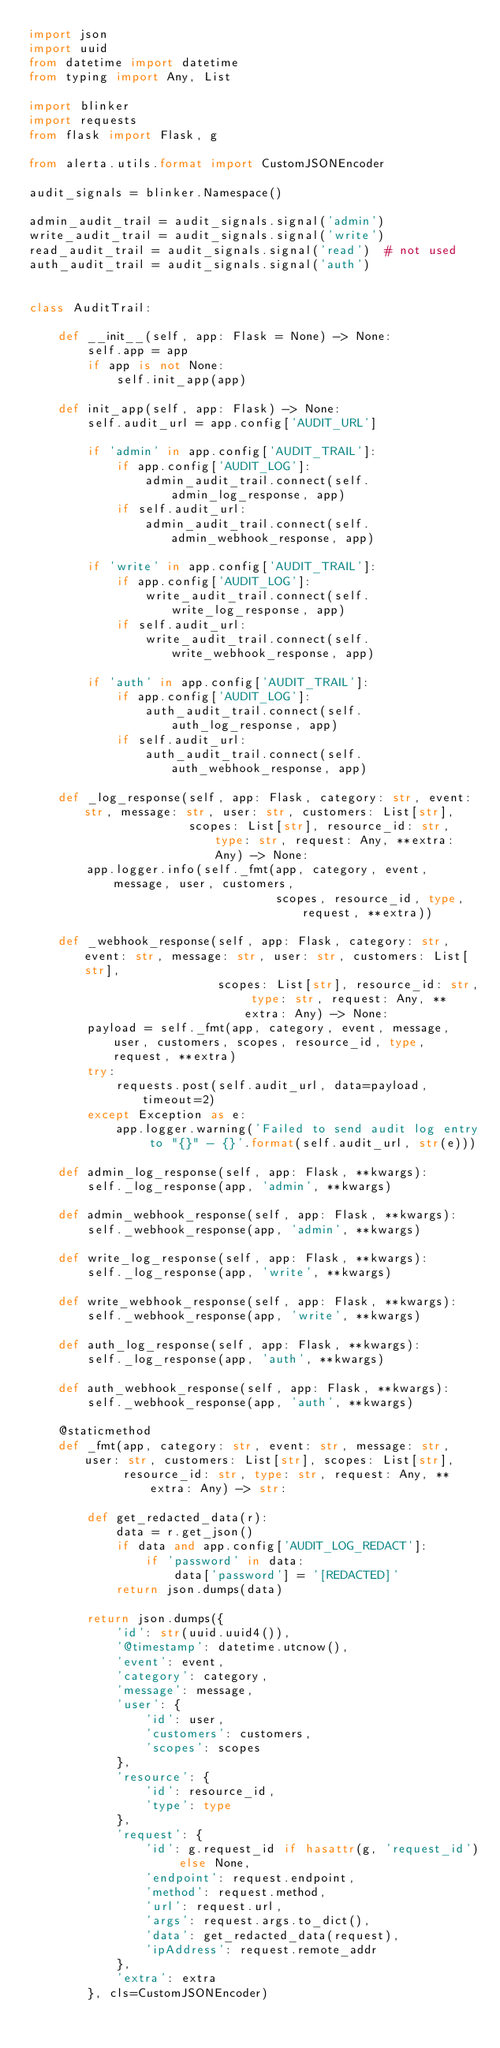<code> <loc_0><loc_0><loc_500><loc_500><_Python_>import json
import uuid
from datetime import datetime
from typing import Any, List

import blinker
import requests
from flask import Flask, g

from alerta.utils.format import CustomJSONEncoder

audit_signals = blinker.Namespace()

admin_audit_trail = audit_signals.signal('admin')
write_audit_trail = audit_signals.signal('write')
read_audit_trail = audit_signals.signal('read')  # not used
auth_audit_trail = audit_signals.signal('auth')


class AuditTrail:

    def __init__(self, app: Flask = None) -> None:
        self.app = app
        if app is not None:
            self.init_app(app)

    def init_app(self, app: Flask) -> None:
        self.audit_url = app.config['AUDIT_URL']

        if 'admin' in app.config['AUDIT_TRAIL']:
            if app.config['AUDIT_LOG']:
                admin_audit_trail.connect(self.admin_log_response, app)
            if self.audit_url:
                admin_audit_trail.connect(self.admin_webhook_response, app)

        if 'write' in app.config['AUDIT_TRAIL']:
            if app.config['AUDIT_LOG']:
                write_audit_trail.connect(self.write_log_response, app)
            if self.audit_url:
                write_audit_trail.connect(self.write_webhook_response, app)

        if 'auth' in app.config['AUDIT_TRAIL']:
            if app.config['AUDIT_LOG']:
                auth_audit_trail.connect(self.auth_log_response, app)
            if self.audit_url:
                auth_audit_trail.connect(self.auth_webhook_response, app)

    def _log_response(self, app: Flask, category: str, event: str, message: str, user: str, customers: List[str],
                      scopes: List[str], resource_id: str, type: str, request: Any, **extra: Any) -> None:
        app.logger.info(self._fmt(app, category, event, message, user, customers,
                                  scopes, resource_id, type, request, **extra))

    def _webhook_response(self, app: Flask, category: str, event: str, message: str, user: str, customers: List[str],
                          scopes: List[str], resource_id: str, type: str, request: Any, **extra: Any) -> None:
        payload = self._fmt(app, category, event, message, user, customers, scopes, resource_id, type, request, **extra)
        try:
            requests.post(self.audit_url, data=payload, timeout=2)
        except Exception as e:
            app.logger.warning('Failed to send audit log entry to "{}" - {}'.format(self.audit_url, str(e)))

    def admin_log_response(self, app: Flask, **kwargs):
        self._log_response(app, 'admin', **kwargs)

    def admin_webhook_response(self, app: Flask, **kwargs):
        self._webhook_response(app, 'admin', **kwargs)

    def write_log_response(self, app: Flask, **kwargs):
        self._log_response(app, 'write', **kwargs)

    def write_webhook_response(self, app: Flask, **kwargs):
        self._webhook_response(app, 'write', **kwargs)

    def auth_log_response(self, app: Flask, **kwargs):
        self._log_response(app, 'auth', **kwargs)

    def auth_webhook_response(self, app: Flask, **kwargs):
        self._webhook_response(app, 'auth', **kwargs)

    @staticmethod
    def _fmt(app, category: str, event: str, message: str, user: str, customers: List[str], scopes: List[str],
             resource_id: str, type: str, request: Any, **extra: Any) -> str:

        def get_redacted_data(r):
            data = r.get_json()
            if data and app.config['AUDIT_LOG_REDACT']:
                if 'password' in data:
                    data['password'] = '[REDACTED]'
            return json.dumps(data)

        return json.dumps({
            'id': str(uuid.uuid4()),
            '@timestamp': datetime.utcnow(),
            'event': event,
            'category': category,
            'message': message,
            'user': {
                'id': user,
                'customers': customers,
                'scopes': scopes
            },
            'resource': {
                'id': resource_id,
                'type': type
            },
            'request': {
                'id': g.request_id if hasattr(g, 'request_id') else None,
                'endpoint': request.endpoint,
                'method': request.method,
                'url': request.url,
                'args': request.args.to_dict(),
                'data': get_redacted_data(request),
                'ipAddress': request.remote_addr
            },
            'extra': extra
        }, cls=CustomJSONEncoder)
</code> 